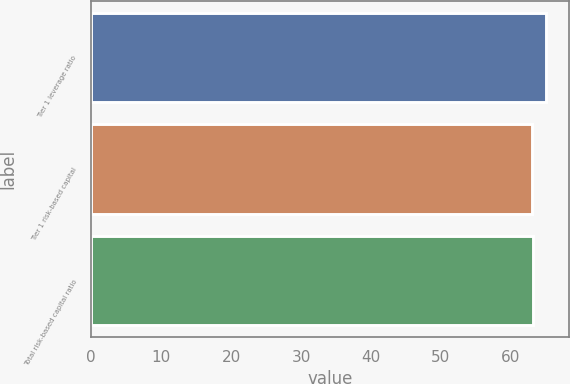<chart> <loc_0><loc_0><loc_500><loc_500><bar_chart><fcel>Tier 1 leverage ratio<fcel>Tier 1 risk-based capital<fcel>Total risk-based capital ratio<nl><fcel>65<fcel>63<fcel>63.2<nl></chart> 